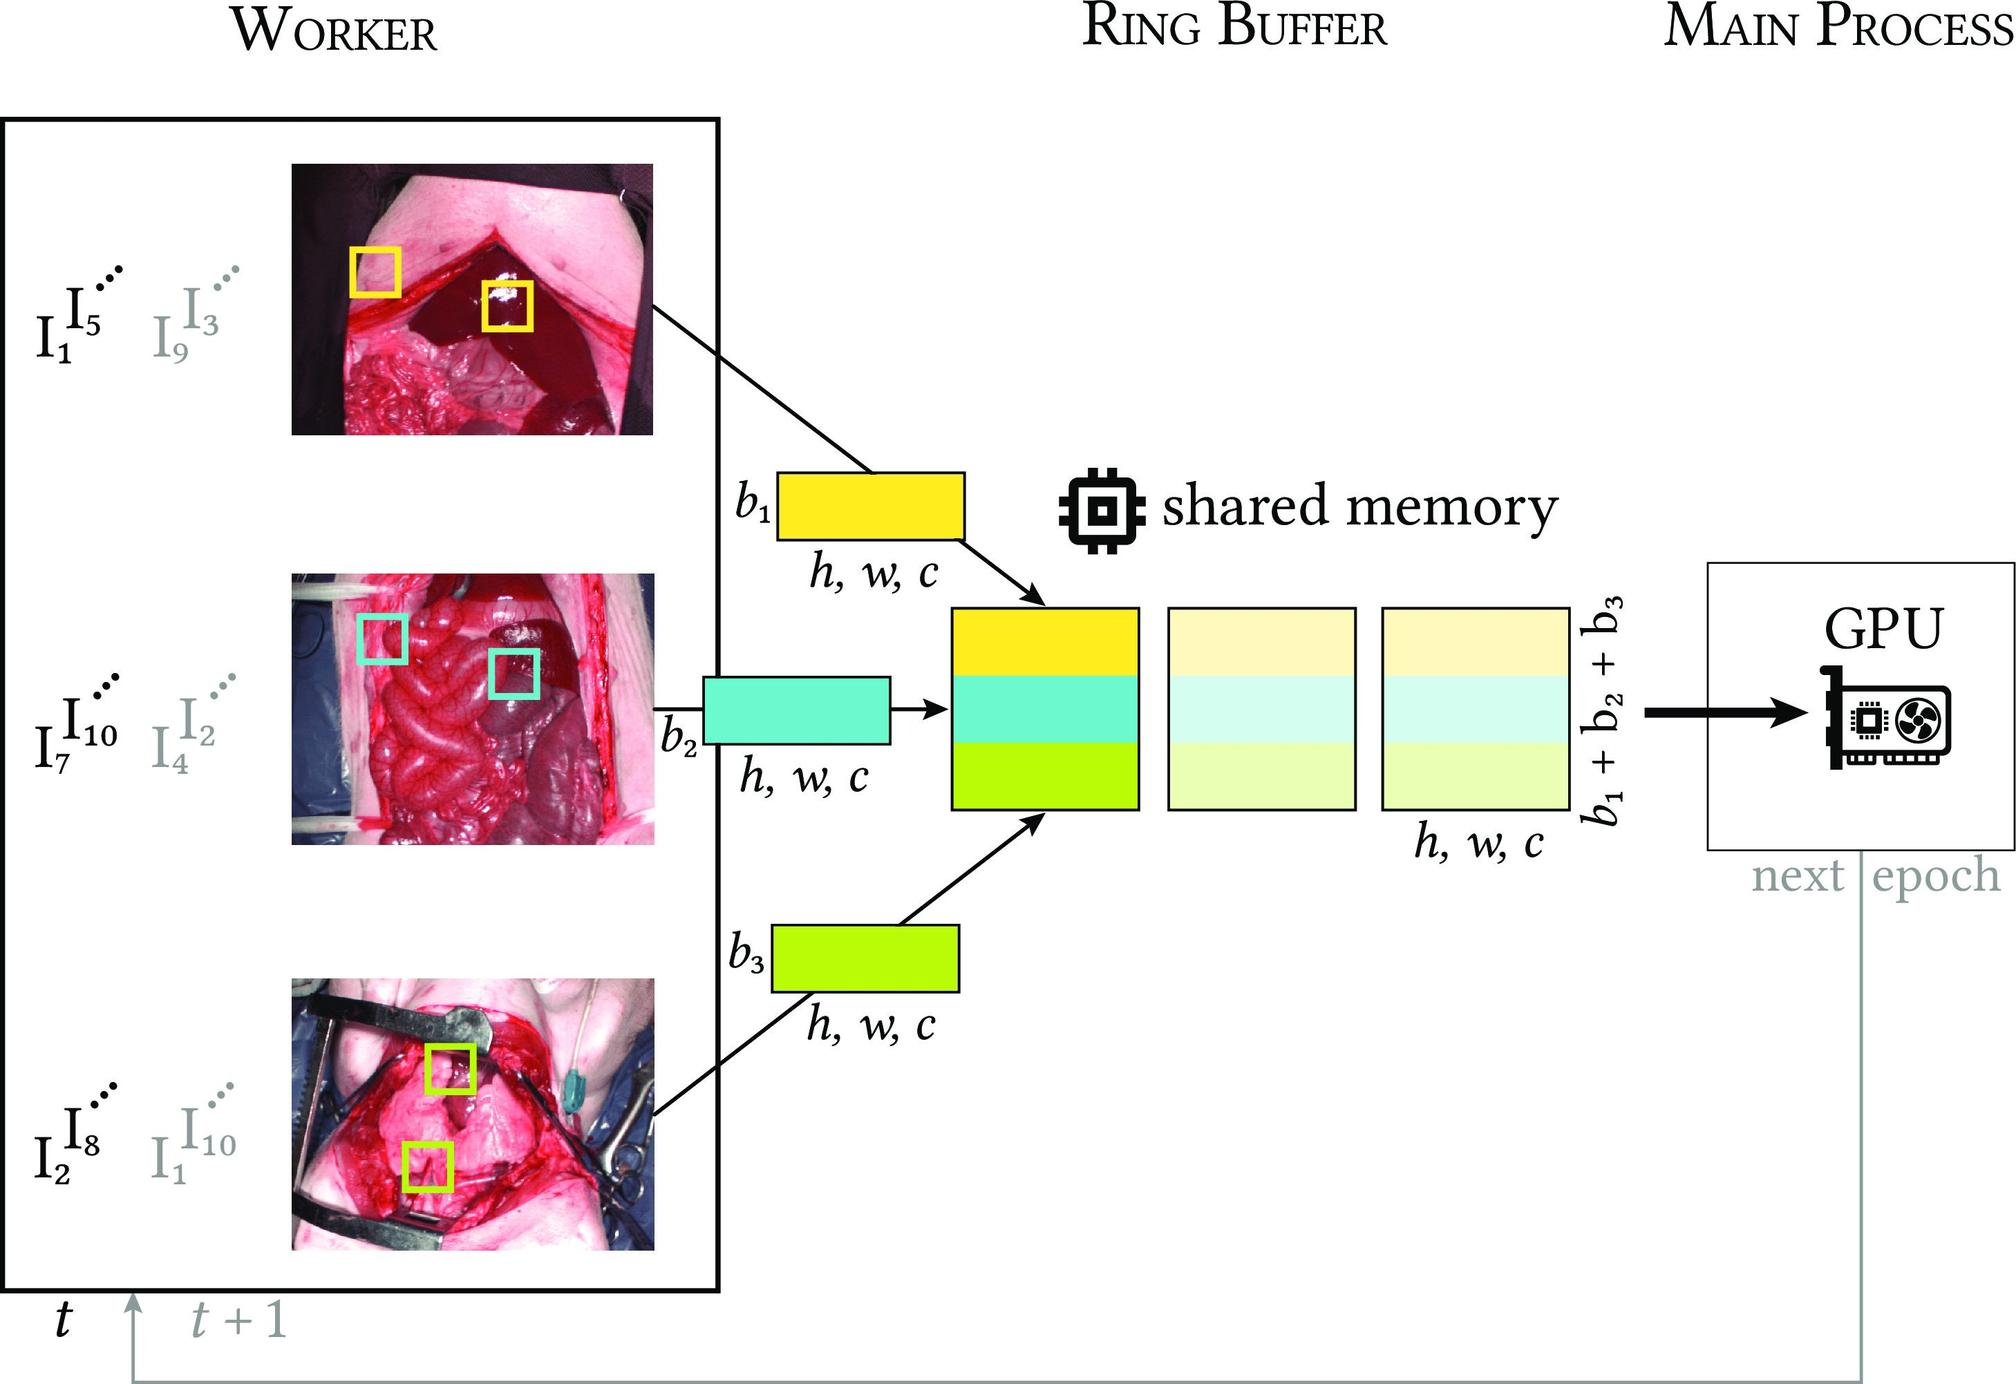Can you explain the functionality of the ring buffer as depicted in this diagram? The ring buffer in the diagram serves as an interim storage point where data can be temporarily held before being processed. It is depicted with several segments (b1, b2, b3), each able to store an image batch. Its design likely aims to optimize the data flow between capture and processing by providing quick access and organized storage. This setup helps in preventing bottlenecks and ensures that data is ready for processing in a structured way as the GPU accesses this data sequentially for processing tasks. 